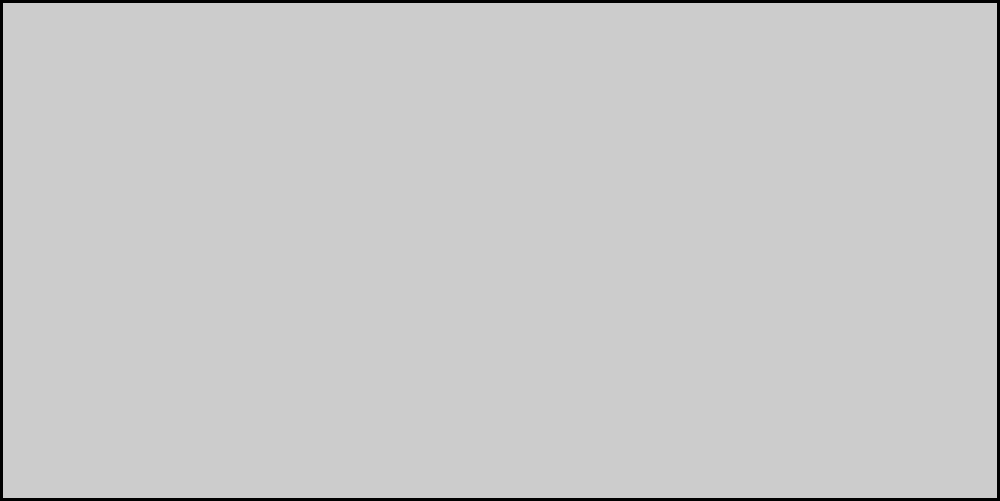In the gecko-inspired adhesive system shown above, what is the primary mechanism responsible for the strong adhesion between the setae and the surface? To understand the adhesive properties of gecko foot-inspired microstructures, we need to follow these steps:

1. Observe the structure: The diagram shows a gecko foot pad with tiny hair-like structures called setae.

2. Identify the contact points: The tips of the setae make contact with the surface.

3. Recognize the force arrows: Small arrows pointing upward from the setae tips indicate an attractive force.

4. Understand the scale: Setae are microscopic structures, typically 30-130 micrometers in length.

5. Consider intermolecular forces: At this scale, van der Waals forces become significant.

6. Van der Waals forces: These are weak electromagnetic forces between molecules or atoms. They occur due to temporary fluctuations in the electron distribution around nuclei.

7. Cumulative effect: While individual van der Waals forces are weak, the cumulative effect of millions of setae creates a strong adhesive force.

8. Reversibility: Unlike chemical adhesives, this physical mechanism allows for easy attachment and detachment.

9. Surface area: The branching structure of setae greatly increases the surface area in contact with the surface, enhancing the overall adhesive effect.

10. Biomimicry application: Understanding this mechanism has led to the development of new adhesive technologies inspired by gecko feet.

The primary mechanism responsible for the strong adhesion is the cumulative effect of van der Waals forces between the numerous setae and the surface.
Answer: Van der Waals forces 